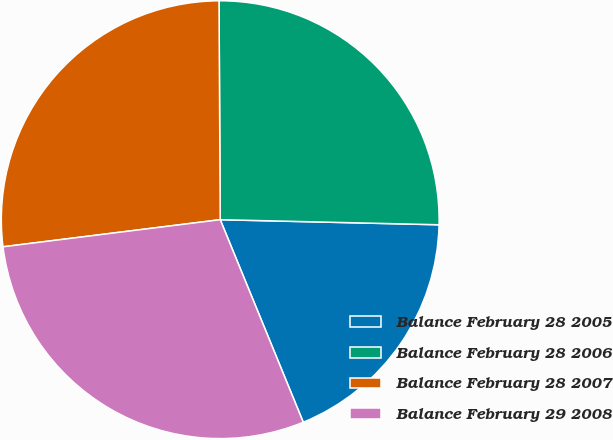Convert chart. <chart><loc_0><loc_0><loc_500><loc_500><pie_chart><fcel>Balance February 28 2005<fcel>Balance February 28 2006<fcel>Balance February 28 2007<fcel>Balance February 29 2008<nl><fcel>18.44%<fcel>25.46%<fcel>26.89%<fcel>29.22%<nl></chart> 